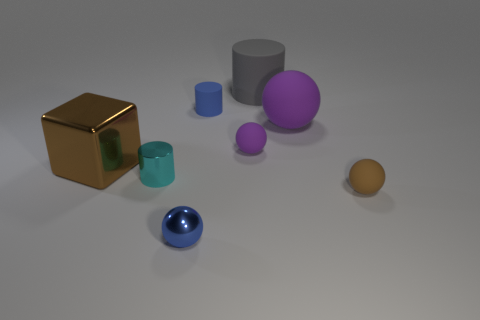Add 1 shiny cylinders. How many objects exist? 9 Subtract all blocks. How many objects are left? 7 Subtract 0 purple cylinders. How many objects are left? 8 Subtract all large cyan metallic blocks. Subtract all metal blocks. How many objects are left? 7 Add 6 metallic spheres. How many metallic spheres are left? 7 Add 7 big yellow rubber balls. How many big yellow rubber balls exist? 7 